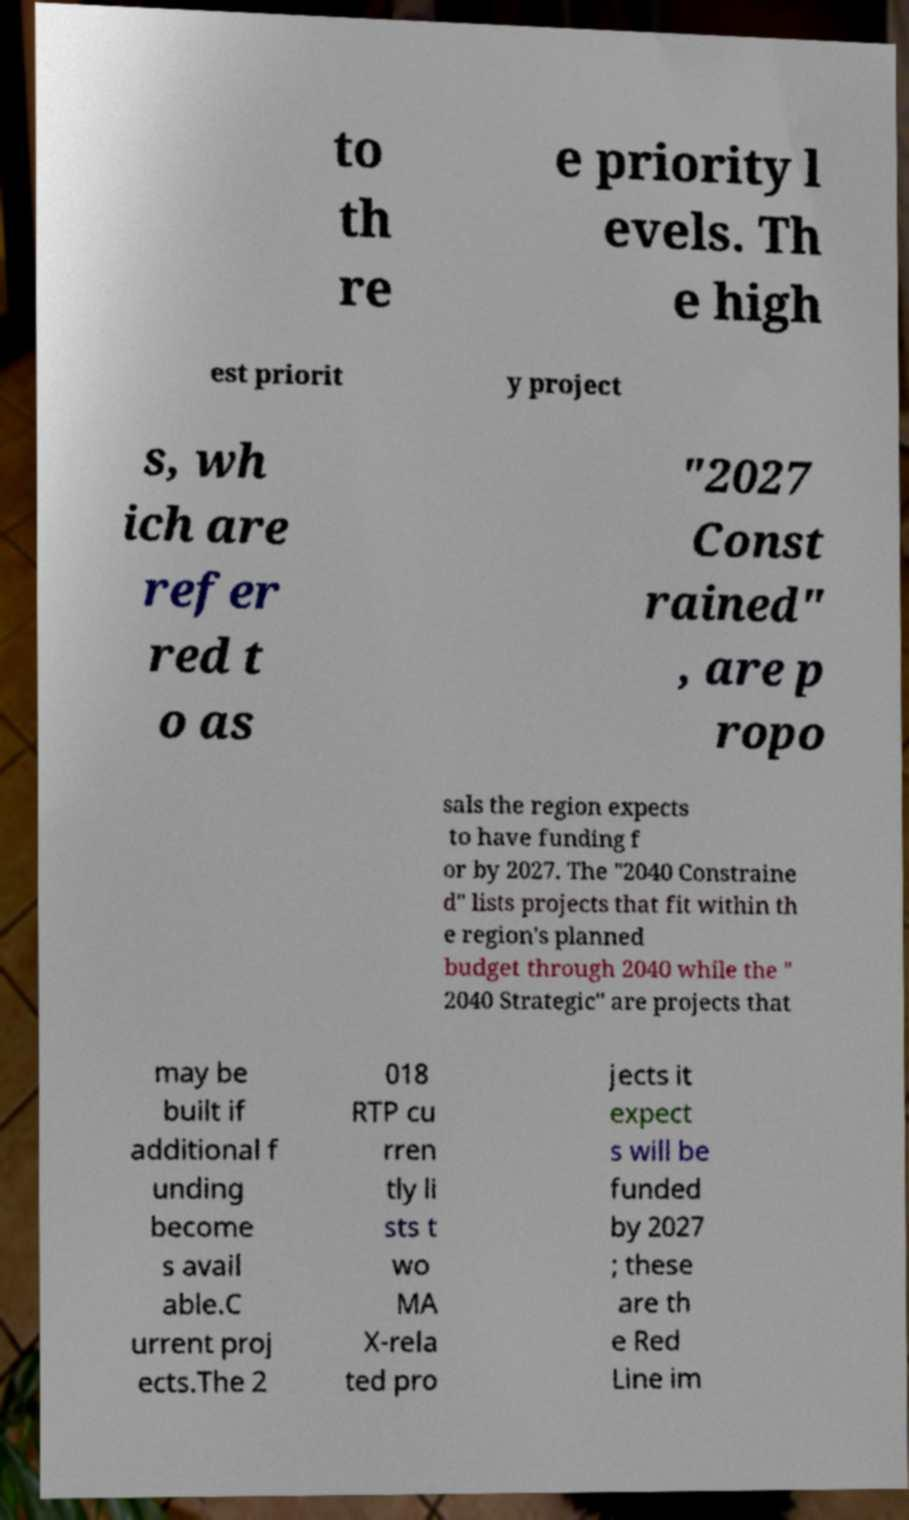Please identify and transcribe the text found in this image. to th re e priority l evels. Th e high est priorit y project s, wh ich are refer red t o as "2027 Const rained" , are p ropo sals the region expects to have funding f or by 2027. The "2040 Constraine d" lists projects that fit within th e region's planned budget through 2040 while the " 2040 Strategic" are projects that may be built if additional f unding become s avail able.C urrent proj ects.The 2 018 RTP cu rren tly li sts t wo MA X-rela ted pro jects it expect s will be funded by 2027 ; these are th e Red Line im 